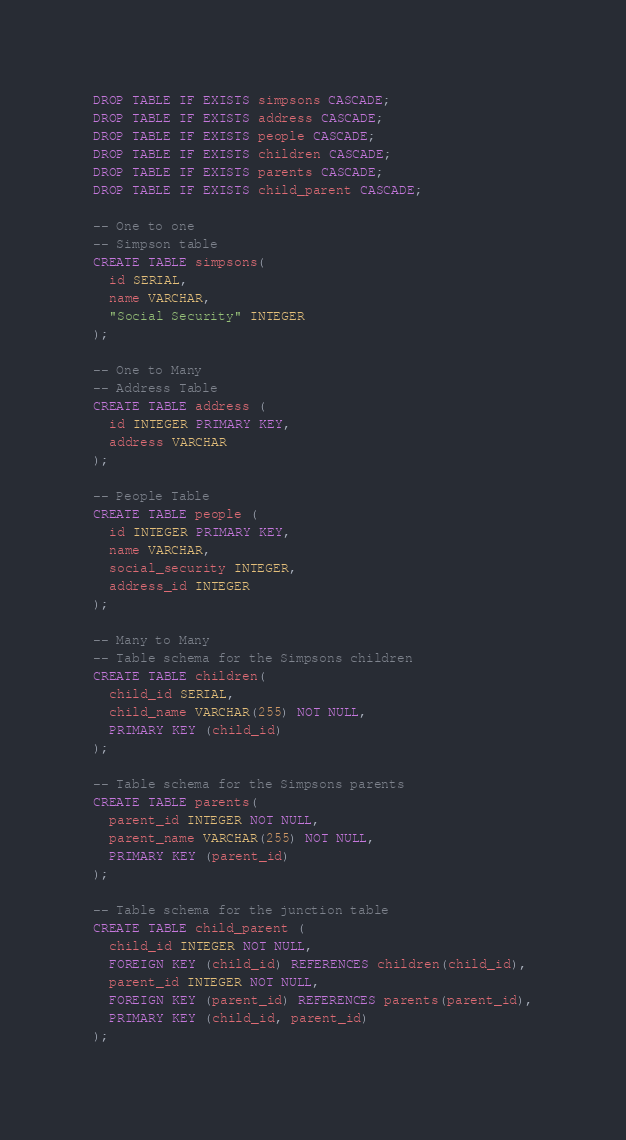<code> <loc_0><loc_0><loc_500><loc_500><_SQL_>DROP TABLE IF EXISTS simpsons CASCADE;
DROP TABLE IF EXISTS address CASCADE;
DROP TABLE IF EXISTS people CASCADE;
DROP TABLE IF EXISTS children CASCADE;
DROP TABLE IF EXISTS parents CASCADE;
DROP TABLE IF EXISTS child_parent CASCADE;

-- One to one
-- Simpson table
CREATE TABLE simpsons(
  id SERIAL,
  name VARCHAR,
  "Social Security" INTEGER
);

-- One to Many
-- Address Table
CREATE TABLE address (
  id INTEGER PRIMARY KEY,
  address VARCHAR
);

-- People Table
CREATE TABLE people (
  id INTEGER PRIMARY KEY,
  name VARCHAR,
  social_security INTEGER,
  address_id INTEGER
);

-- Many to Many
-- Table schema for the Simpsons children
CREATE TABLE children(
  child_id SERIAL,
  child_name VARCHAR(255) NOT NULL,
  PRIMARY KEY (child_id)
);

-- Table schema for the Simpsons parents
CREATE TABLE parents(
  parent_id INTEGER NOT NULL,
  parent_name VARCHAR(255) NOT NULL,
  PRIMARY KEY (parent_id)
);

-- Table schema for the junction table
CREATE TABLE child_parent (
  child_id INTEGER NOT NULL,
  FOREIGN KEY (child_id) REFERENCES children(child_id),
  parent_id INTEGER NOT NULL,
  FOREIGN KEY (parent_id) REFERENCES parents(parent_id),
  PRIMARY KEY (child_id, parent_id)
);
</code> 